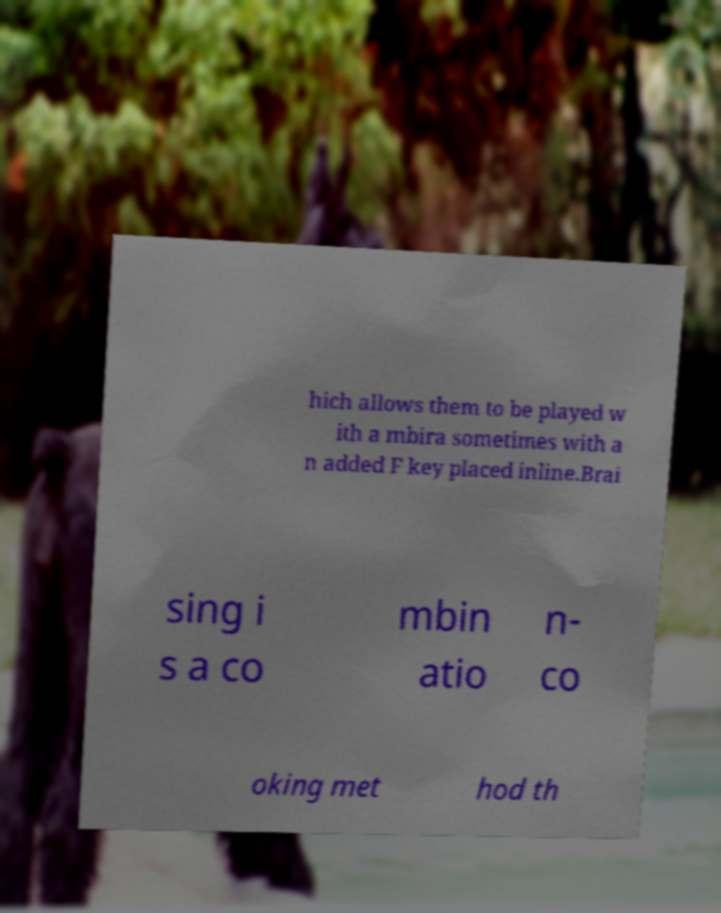Can you read and provide the text displayed in the image?This photo seems to have some interesting text. Can you extract and type it out for me? hich allows them to be played w ith a mbira sometimes with a n added F key placed inline.Brai sing i s a co mbin atio n- co oking met hod th 